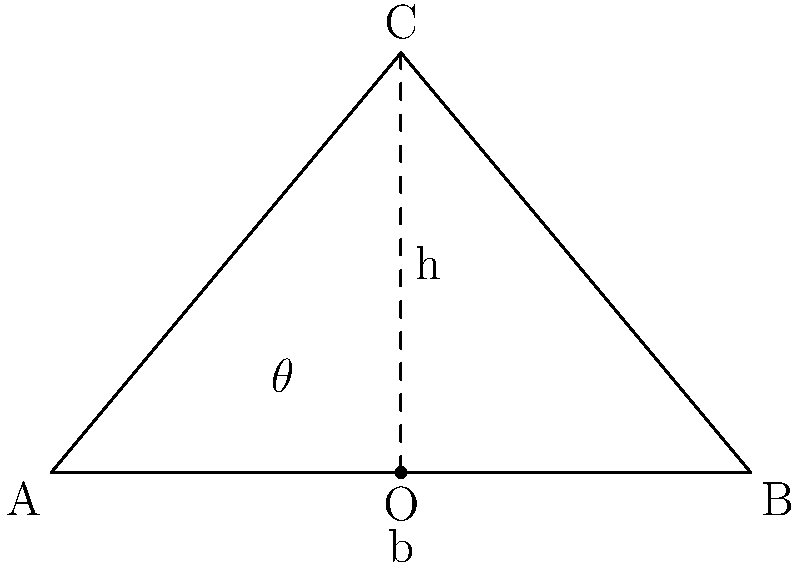In your hometown of Äyşiyaz, traditional houses often have sloped roofs to manage heavy rainfall. As a civil engineer working in a big city, you're designing a similar roof structure. Given a roof with base width $b = 5$ meters and height $h = 3$ meters, what is the optimal angle $\theta$ for maximizing rainwater runoff? To determine the optimal angle for maximizing rainwater runoff, we need to consider the following steps:

1. Understand the relationship between slope and runoff:
   - A steeper slope generally leads to faster water runoff.
   - However, extremely steep slopes can cause water to "bounce off" the roof, reducing effective runoff.

2. Calculate the current roof angle:
   - We can use the trigonometric relationship in a right triangle.
   - $\tan \theta = \frac{\text{opposite}}{\text{adjacent}} = \frac{h}{\frac{b}{2}} = \frac{2h}{b}$
   - $\tan \theta = \frac{2 \cdot 3}{5} = \frac{6}{5} = 1.2$
   - $\theta = \arctan(1.2) \approx 50.2°$

3. Consider optimal roof angles:
   - In general, the optimal angle for roof slopes in areas with moderate to heavy rainfall is between 30° and 45°.
   - This range balances effective water runoff with practical construction considerations.

4. Compare the calculated angle to the optimal range:
   - The calculated angle (50.2°) is slightly higher than the optimal range.
   - While this angle will provide good runoff, it might be steeper than necessary and could increase construction costs.

5. Recommend an optimal angle:
   - Given the heavy rainfall in Äyşiyaz, an angle at the upper end of the optimal range would be suitable.
   - A 45° angle would maximize runoff while staying within practical construction limits.

Therefore, the optimal angle for maximizing rainwater runoff in this situation would be 45°.
Answer: 45° 